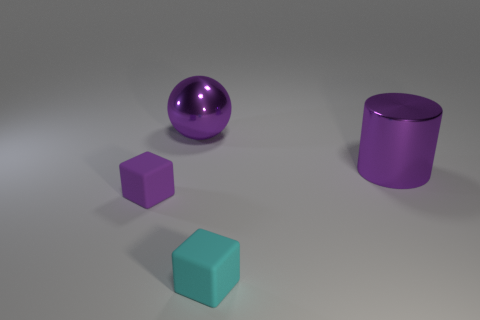Add 4 small red shiny cylinders. How many objects exist? 8 Subtract all cylinders. How many objects are left? 3 Add 2 big purple metal things. How many big purple metal things are left? 4 Add 3 rubber objects. How many rubber objects exist? 5 Subtract 1 purple blocks. How many objects are left? 3 Subtract all small cyan spheres. Subtract all big purple cylinders. How many objects are left? 3 